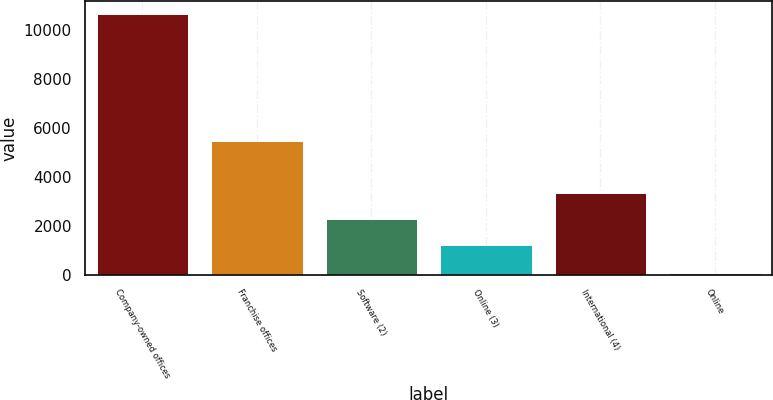Convert chart to OTSL. <chart><loc_0><loc_0><loc_500><loc_500><bar_chart><fcel>Company-owned offices<fcel>Franchise offices<fcel>Software (2)<fcel>Online (3)<fcel>International (4)<fcel>Online<nl><fcel>10627<fcel>5460<fcel>2264<fcel>1207<fcel>3321<fcel>57<nl></chart> 